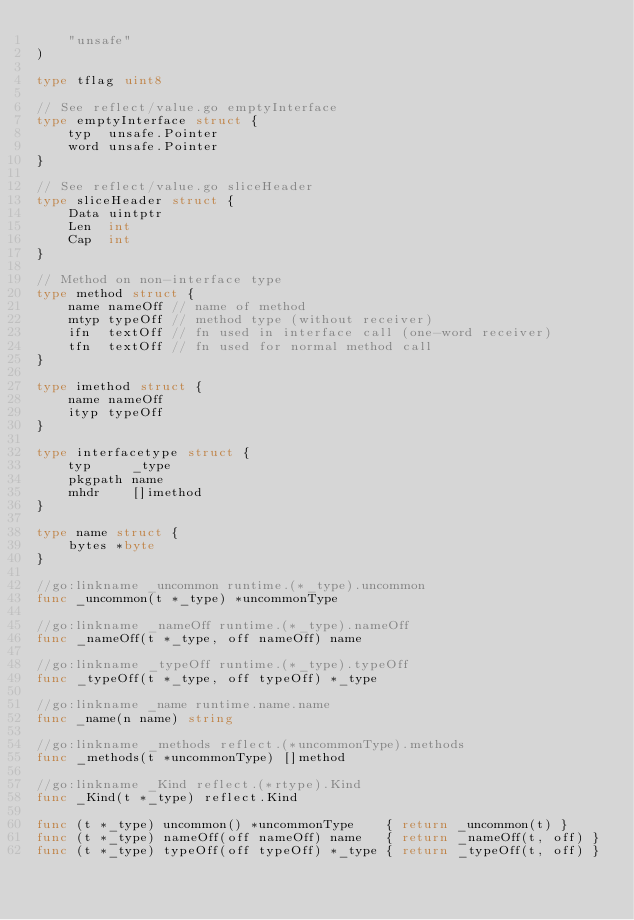<code> <loc_0><loc_0><loc_500><loc_500><_Go_>	"unsafe"
)

type tflag uint8

// See reflect/value.go emptyInterface
type emptyInterface struct {
	typ  unsafe.Pointer
	word unsafe.Pointer
}

// See reflect/value.go sliceHeader
type sliceHeader struct {
	Data uintptr
	Len  int
	Cap  int
}

// Method on non-interface type
type method struct {
	name nameOff // name of method
	mtyp typeOff // method type (without receiver)
	ifn  textOff // fn used in interface call (one-word receiver)
	tfn  textOff // fn used for normal method call
}

type imethod struct {
	name nameOff
	ityp typeOff
}

type interfacetype struct {
	typ     _type
	pkgpath name
	mhdr    []imethod
}

type name struct {
	bytes *byte
}

//go:linkname _uncommon runtime.(*_type).uncommon
func _uncommon(t *_type) *uncommonType

//go:linkname _nameOff runtime.(*_type).nameOff
func _nameOff(t *_type, off nameOff) name

//go:linkname _typeOff runtime.(*_type).typeOff
func _typeOff(t *_type, off typeOff) *_type

//go:linkname _name runtime.name.name
func _name(n name) string

//go:linkname _methods reflect.(*uncommonType).methods
func _methods(t *uncommonType) []method

//go:linkname _Kind reflect.(*rtype).Kind
func _Kind(t *_type) reflect.Kind

func (t *_type) uncommon() *uncommonType    { return _uncommon(t) }
func (t *_type) nameOff(off nameOff) name   { return _nameOff(t, off) }
func (t *_type) typeOff(off typeOff) *_type { return _typeOff(t, off) }</code> 